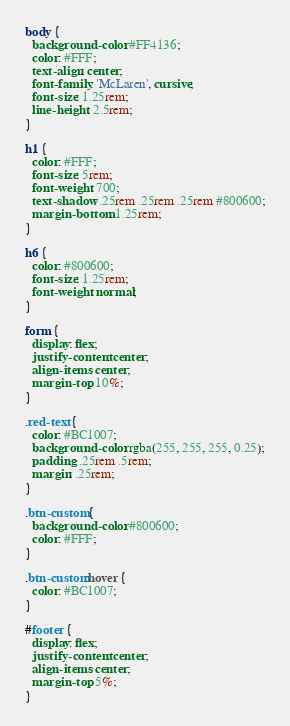<code> <loc_0><loc_0><loc_500><loc_500><_CSS_>body {
  background-color: #FF4136;
  color: #FFF;
  text-align: center;
  font-family: 'McLaren', cursive;
  font-size: 1.25rem;
  line-height: 2.5rem;
}

h1 {
  color: #FFF;
  font-size: 5rem;
  font-weight: 700;
  text-shadow: .25rem .25rem .25rem #800600;
  margin-bottom: 1.25rem;
}

h6 {
  color: #800600;
  font-size: 1.25rem;
  font-weight: normal;
}

form {
  display: flex;
  justify-content: center;
  align-items: center;
  margin-top: 10%;
}

.red-text {
  color: #BC1007;
  background-color: rgba(255, 255, 255, 0.25);
  padding: .25rem .5rem;
  margin: .25rem;
}

.btn-custom {
  background-color: #800600;
  color: #FFF;
}

.btn-custom:hover {
  color: #BC1007;
}

#footer {
  display: flex;
  justify-content: center;
  align-items: center;
  margin-top: 5%;
}
</code> 